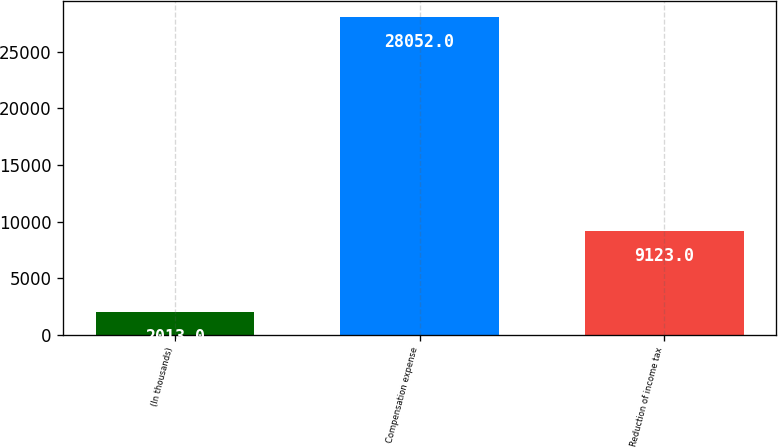Convert chart. <chart><loc_0><loc_0><loc_500><loc_500><bar_chart><fcel>(In thousands)<fcel>Compensation expense<fcel>Reduction of income tax<nl><fcel>2013<fcel>28052<fcel>9123<nl></chart> 